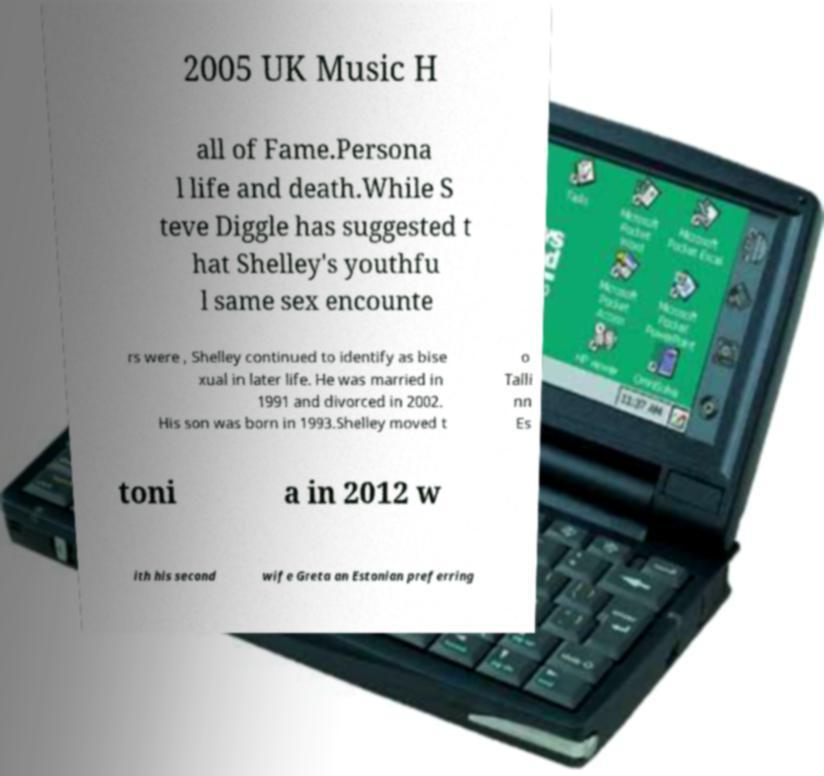Please identify and transcribe the text found in this image. 2005 UK Music H all of Fame.Persona l life and death.While S teve Diggle has suggested t hat Shelley's youthfu l same sex encounte rs were , Shelley continued to identify as bise xual in later life. He was married in 1991 and divorced in 2002. His son was born in 1993.Shelley moved t o Talli nn Es toni a in 2012 w ith his second wife Greta an Estonian preferring 